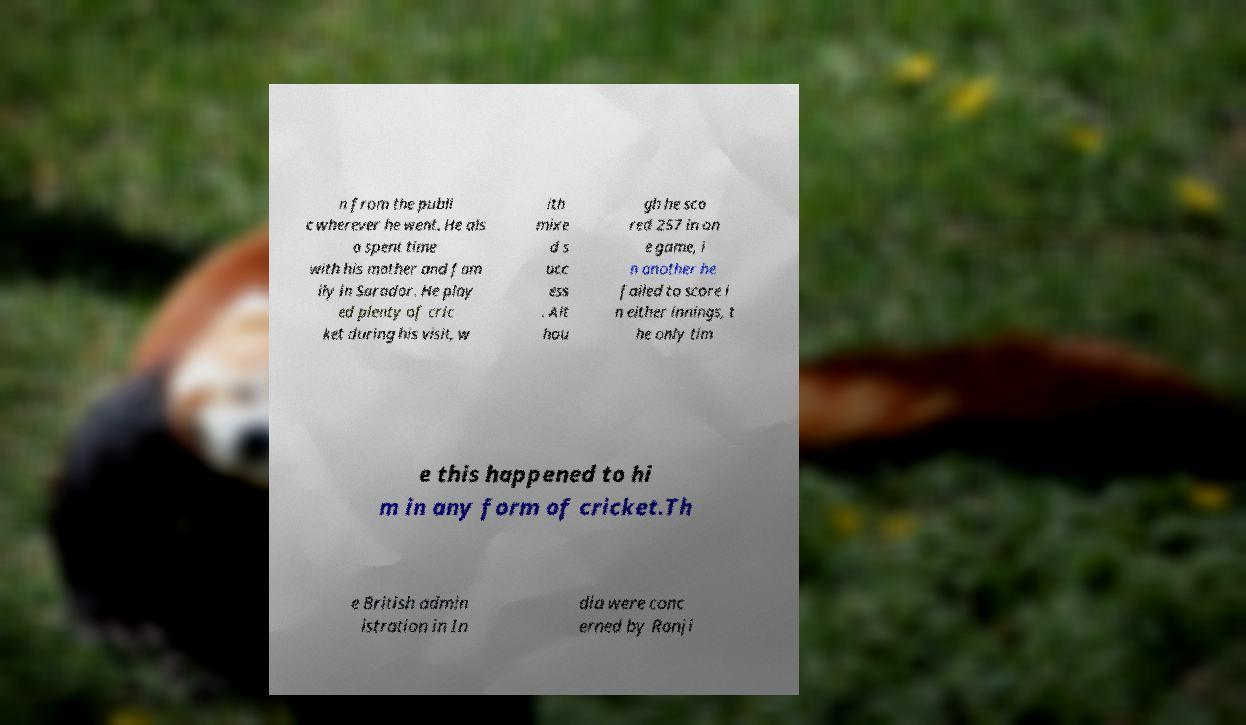Can you read and provide the text displayed in the image?This photo seems to have some interesting text. Can you extract and type it out for me? n from the publi c wherever he went. He als o spent time with his mother and fam ily in Sarador. He play ed plenty of cric ket during his visit, w ith mixe d s ucc ess . Alt hou gh he sco red 257 in on e game, i n another he failed to score i n either innings, t he only tim e this happened to hi m in any form of cricket.Th e British admin istration in In dia were conc erned by Ranji 